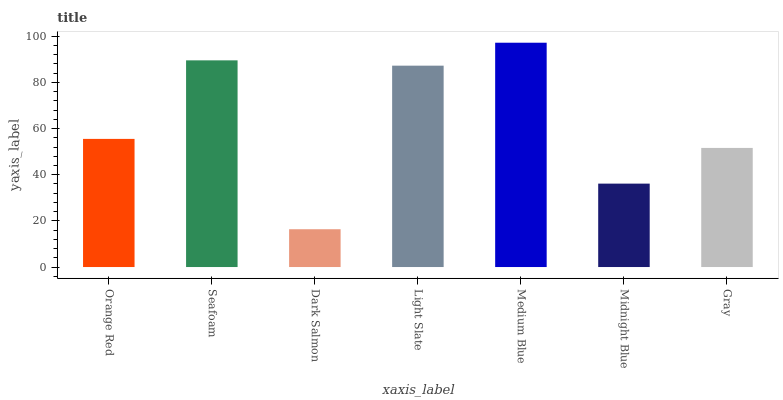Is Dark Salmon the minimum?
Answer yes or no. Yes. Is Medium Blue the maximum?
Answer yes or no. Yes. Is Seafoam the minimum?
Answer yes or no. No. Is Seafoam the maximum?
Answer yes or no. No. Is Seafoam greater than Orange Red?
Answer yes or no. Yes. Is Orange Red less than Seafoam?
Answer yes or no. Yes. Is Orange Red greater than Seafoam?
Answer yes or no. No. Is Seafoam less than Orange Red?
Answer yes or no. No. Is Orange Red the high median?
Answer yes or no. Yes. Is Orange Red the low median?
Answer yes or no. Yes. Is Light Slate the high median?
Answer yes or no. No. Is Gray the low median?
Answer yes or no. No. 